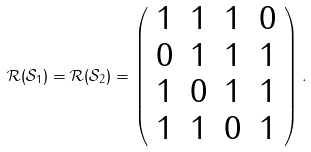<formula> <loc_0><loc_0><loc_500><loc_500>\mathcal { R } ( \mathcal { S } _ { 1 } ) = \mathcal { R } ( \mathcal { S } _ { 2 } ) = \left ( \begin{array} { c c c c } 1 & 1 & 1 & 0 \\ 0 & 1 & 1 & 1 \\ 1 & 0 & 1 & 1 \\ 1 & 1 & 0 & 1 \end{array} \right ) .</formula> 